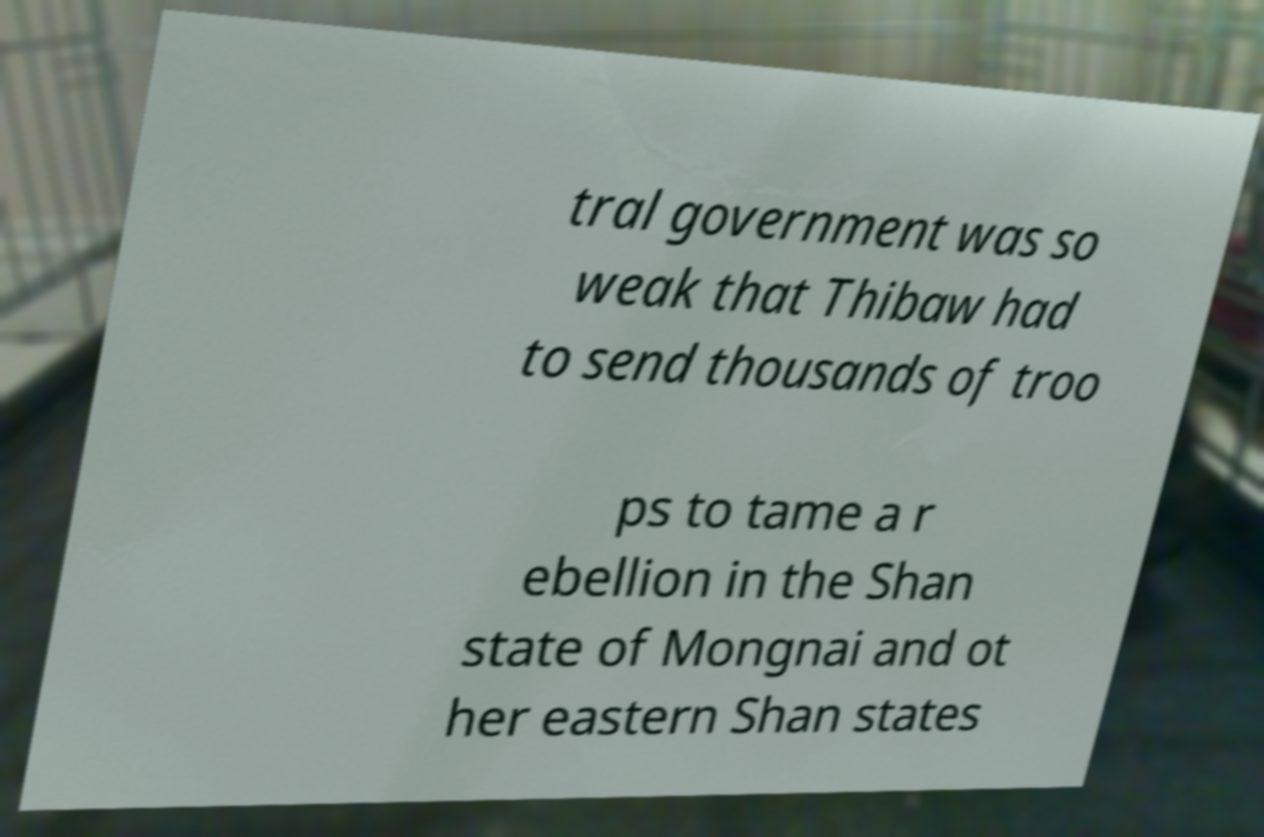What messages or text are displayed in this image? I need them in a readable, typed format. tral government was so weak that Thibaw had to send thousands of troo ps to tame a r ebellion in the Shan state of Mongnai and ot her eastern Shan states 